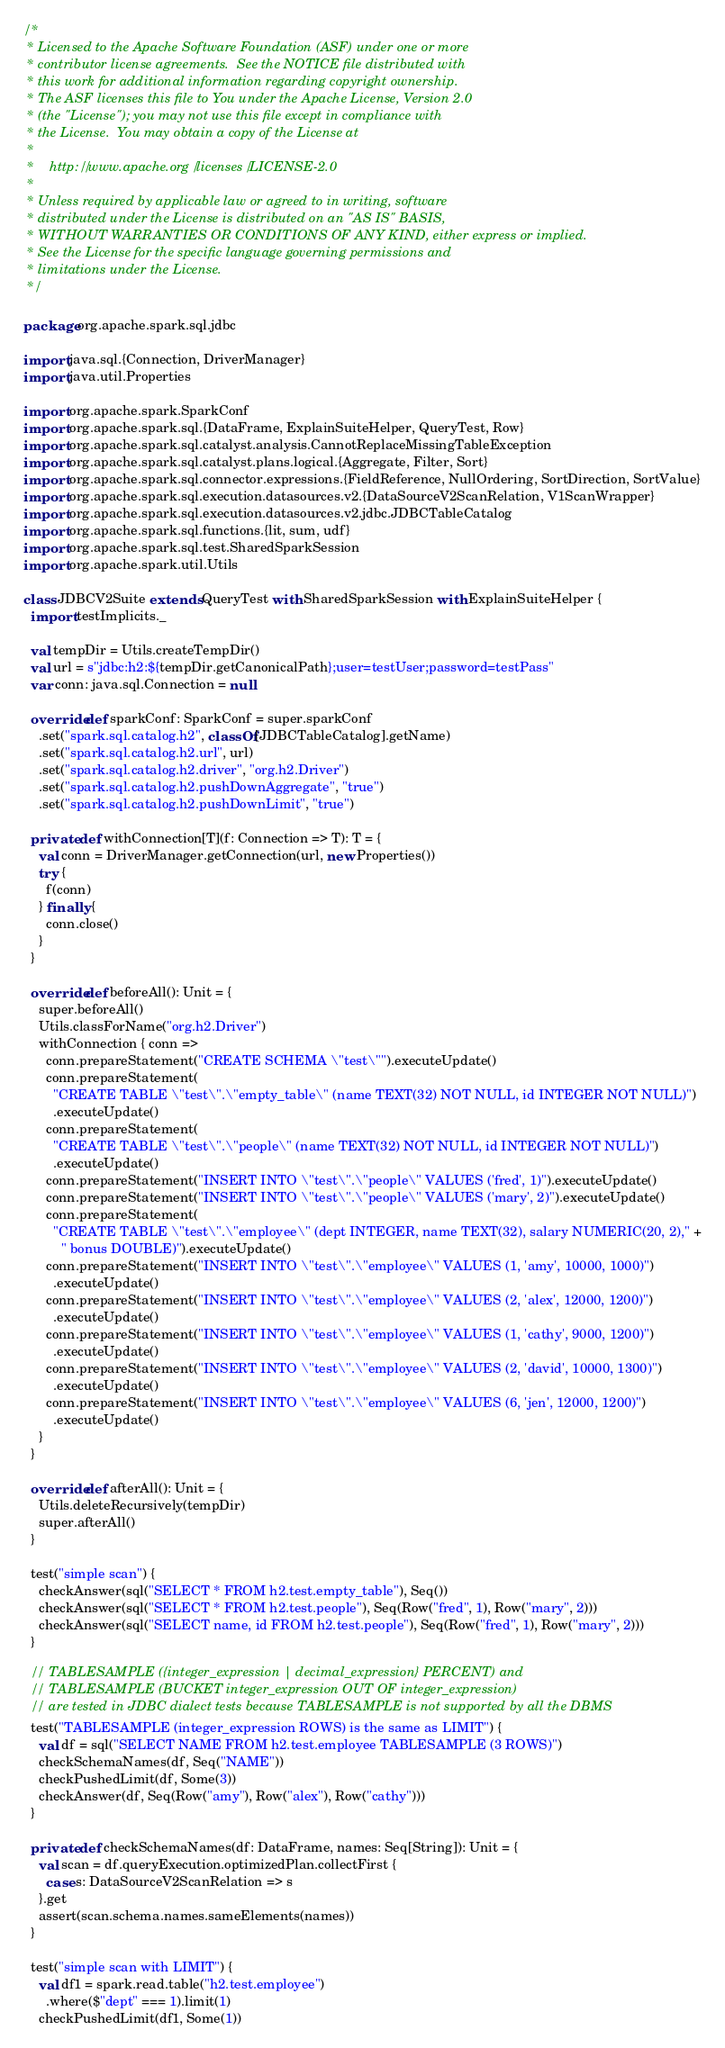<code> <loc_0><loc_0><loc_500><loc_500><_Scala_>/*
 * Licensed to the Apache Software Foundation (ASF) under one or more
 * contributor license agreements.  See the NOTICE file distributed with
 * this work for additional information regarding copyright ownership.
 * The ASF licenses this file to You under the Apache License, Version 2.0
 * (the "License"); you may not use this file except in compliance with
 * the License.  You may obtain a copy of the License at
 *
 *    http://www.apache.org/licenses/LICENSE-2.0
 *
 * Unless required by applicable law or agreed to in writing, software
 * distributed under the License is distributed on an "AS IS" BASIS,
 * WITHOUT WARRANTIES OR CONDITIONS OF ANY KIND, either express or implied.
 * See the License for the specific language governing permissions and
 * limitations under the License.
 */

package org.apache.spark.sql.jdbc

import java.sql.{Connection, DriverManager}
import java.util.Properties

import org.apache.spark.SparkConf
import org.apache.spark.sql.{DataFrame, ExplainSuiteHelper, QueryTest, Row}
import org.apache.spark.sql.catalyst.analysis.CannotReplaceMissingTableException
import org.apache.spark.sql.catalyst.plans.logical.{Aggregate, Filter, Sort}
import org.apache.spark.sql.connector.expressions.{FieldReference, NullOrdering, SortDirection, SortValue}
import org.apache.spark.sql.execution.datasources.v2.{DataSourceV2ScanRelation, V1ScanWrapper}
import org.apache.spark.sql.execution.datasources.v2.jdbc.JDBCTableCatalog
import org.apache.spark.sql.functions.{lit, sum, udf}
import org.apache.spark.sql.test.SharedSparkSession
import org.apache.spark.util.Utils

class JDBCV2Suite extends QueryTest with SharedSparkSession with ExplainSuiteHelper {
  import testImplicits._

  val tempDir = Utils.createTempDir()
  val url = s"jdbc:h2:${tempDir.getCanonicalPath};user=testUser;password=testPass"
  var conn: java.sql.Connection = null

  override def sparkConf: SparkConf = super.sparkConf
    .set("spark.sql.catalog.h2", classOf[JDBCTableCatalog].getName)
    .set("spark.sql.catalog.h2.url", url)
    .set("spark.sql.catalog.h2.driver", "org.h2.Driver")
    .set("spark.sql.catalog.h2.pushDownAggregate", "true")
    .set("spark.sql.catalog.h2.pushDownLimit", "true")

  private def withConnection[T](f: Connection => T): T = {
    val conn = DriverManager.getConnection(url, new Properties())
    try {
      f(conn)
    } finally {
      conn.close()
    }
  }

  override def beforeAll(): Unit = {
    super.beforeAll()
    Utils.classForName("org.h2.Driver")
    withConnection { conn =>
      conn.prepareStatement("CREATE SCHEMA \"test\"").executeUpdate()
      conn.prepareStatement(
        "CREATE TABLE \"test\".\"empty_table\" (name TEXT(32) NOT NULL, id INTEGER NOT NULL)")
        .executeUpdate()
      conn.prepareStatement(
        "CREATE TABLE \"test\".\"people\" (name TEXT(32) NOT NULL, id INTEGER NOT NULL)")
        .executeUpdate()
      conn.prepareStatement("INSERT INTO \"test\".\"people\" VALUES ('fred', 1)").executeUpdate()
      conn.prepareStatement("INSERT INTO \"test\".\"people\" VALUES ('mary', 2)").executeUpdate()
      conn.prepareStatement(
        "CREATE TABLE \"test\".\"employee\" (dept INTEGER, name TEXT(32), salary NUMERIC(20, 2)," +
          " bonus DOUBLE)").executeUpdate()
      conn.prepareStatement("INSERT INTO \"test\".\"employee\" VALUES (1, 'amy', 10000, 1000)")
        .executeUpdate()
      conn.prepareStatement("INSERT INTO \"test\".\"employee\" VALUES (2, 'alex', 12000, 1200)")
        .executeUpdate()
      conn.prepareStatement("INSERT INTO \"test\".\"employee\" VALUES (1, 'cathy', 9000, 1200)")
        .executeUpdate()
      conn.prepareStatement("INSERT INTO \"test\".\"employee\" VALUES (2, 'david', 10000, 1300)")
        .executeUpdate()
      conn.prepareStatement("INSERT INTO \"test\".\"employee\" VALUES (6, 'jen', 12000, 1200)")
        .executeUpdate()
    }
  }

  override def afterAll(): Unit = {
    Utils.deleteRecursively(tempDir)
    super.afterAll()
  }

  test("simple scan") {
    checkAnswer(sql("SELECT * FROM h2.test.empty_table"), Seq())
    checkAnswer(sql("SELECT * FROM h2.test.people"), Seq(Row("fred", 1), Row("mary", 2)))
    checkAnswer(sql("SELECT name, id FROM h2.test.people"), Seq(Row("fred", 1), Row("mary", 2)))
  }

  // TABLESAMPLE ({integer_expression | decimal_expression} PERCENT) and
  // TABLESAMPLE (BUCKET integer_expression OUT OF integer_expression)
  // are tested in JDBC dialect tests because TABLESAMPLE is not supported by all the DBMS
  test("TABLESAMPLE (integer_expression ROWS) is the same as LIMIT") {
    val df = sql("SELECT NAME FROM h2.test.employee TABLESAMPLE (3 ROWS)")
    checkSchemaNames(df, Seq("NAME"))
    checkPushedLimit(df, Some(3))
    checkAnswer(df, Seq(Row("amy"), Row("alex"), Row("cathy")))
  }

  private def checkSchemaNames(df: DataFrame, names: Seq[String]): Unit = {
    val scan = df.queryExecution.optimizedPlan.collectFirst {
      case s: DataSourceV2ScanRelation => s
    }.get
    assert(scan.schema.names.sameElements(names))
  }

  test("simple scan with LIMIT") {
    val df1 = spark.read.table("h2.test.employee")
      .where($"dept" === 1).limit(1)
    checkPushedLimit(df1, Some(1))</code> 